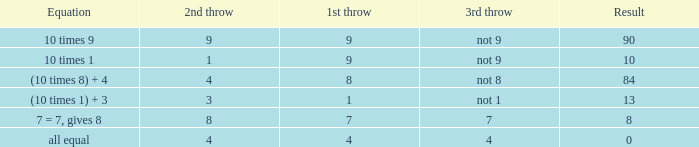If the equation is (10 times 1) + 3, what is the 2nd throw? 3.0. 